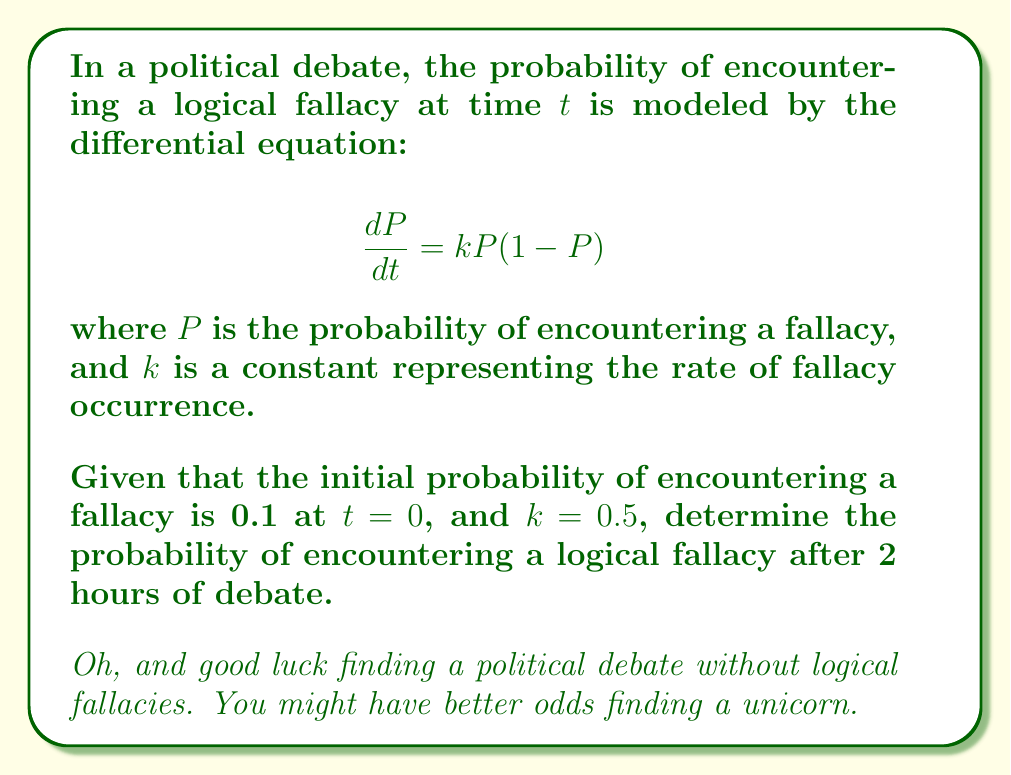Solve this math problem. Alright, let's tackle this with the appropriate level of skepticism:

1) We're dealing with a logistic differential equation. The solution to this equation is:

   $$P(t) = \frac{P_0e^{kt}}{1-P_0+P_0e^{kt}}$$

   where $P_0$ is the initial probability.

2) We're given:
   - $P_0 = 0.1$ (initial probability)
   - $k = 0.5$ (rate constant)
   - $t = 2$ (time in hours)

3) Let's plug these values into our equation:

   $$P(2) = \frac{0.1e^{0.5(2)}}{1-0.1+0.1e^{0.5(2)}}$$

4) Simplify the exponent:
   
   $$P(2) = \frac{0.1e^1}{0.9+0.1e^1}$$

5) Calculate $e^1 \approx 2.71828$:

   $$P(2) \approx \frac{0.1(2.71828)}{0.9+0.1(2.71828)}$$

6) Multiply out the numerator and denominator:

   $$P(2) \approx \frac{0.271828}{0.9+0.271828} = \frac{0.271828}{1.171828}$$

7) Divide:

   $$P(2) \approx 0.232$$

So, after 2 hours, the probability of encountering a logical fallacy is approximately 0.232 or 23.2%.

Surprisingly low, isn't it? But remember, this is just a model. In reality, you might want to bump that up to about 99.9%.
Answer: $P(2) \approx 0.232$ 